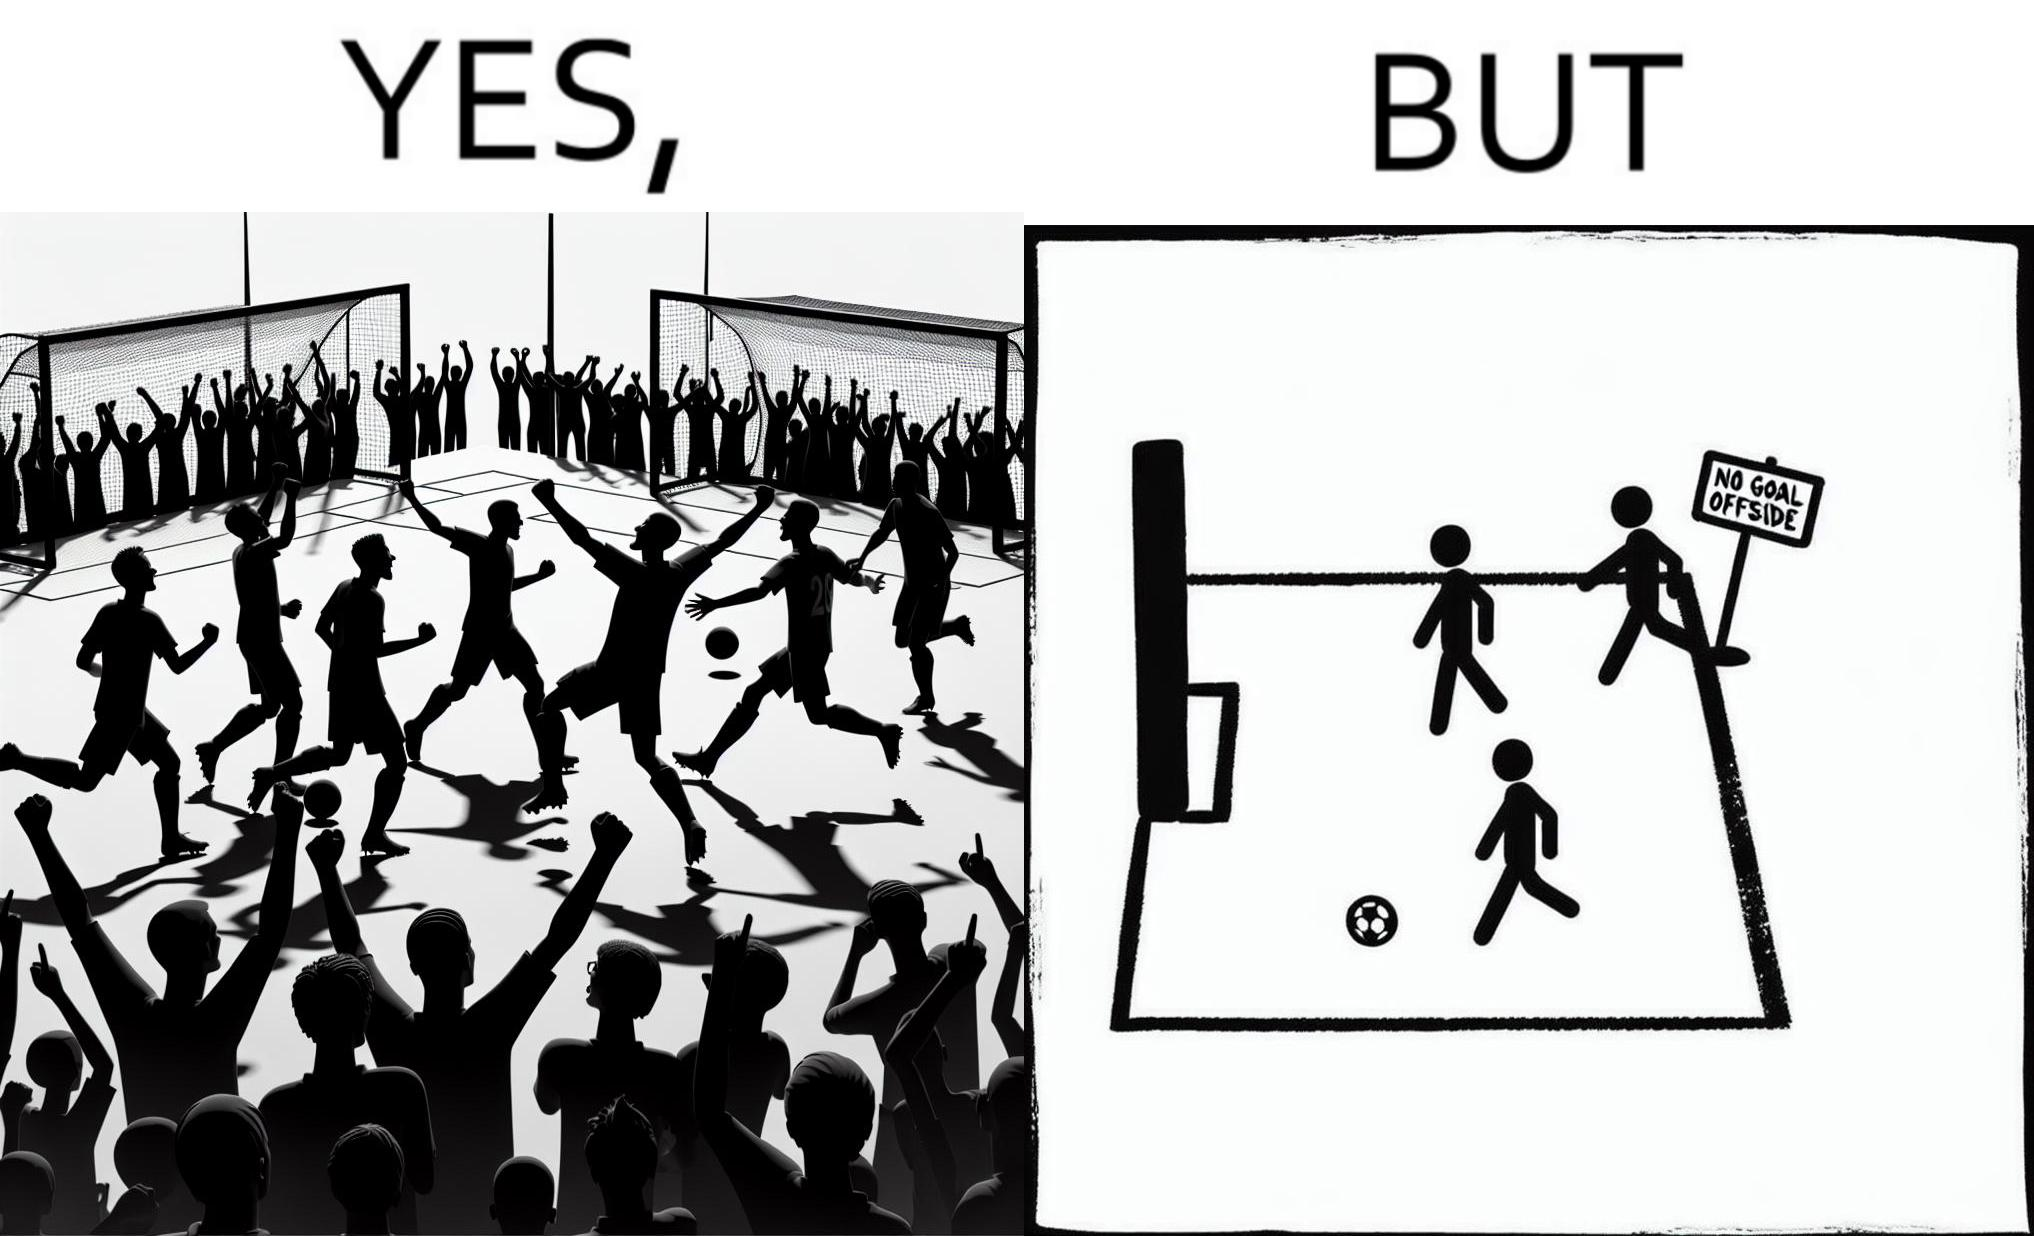Is this image satirical or non-satirical? Yes, this image is satirical. 